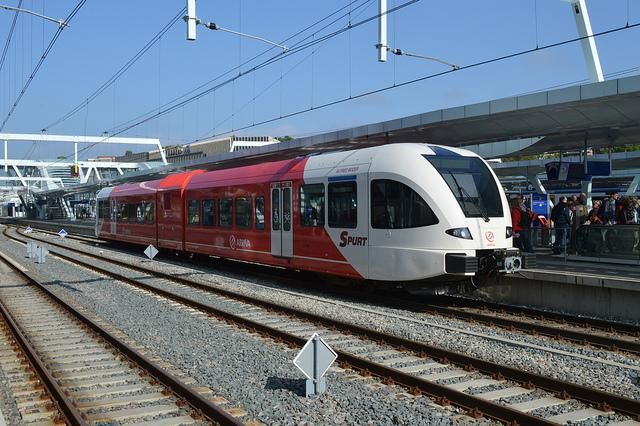What type power does this train use? Please explain your reasoning. electrical. The train does not have an internal combustion engine. it uses the power lines that hang above the tracks. 